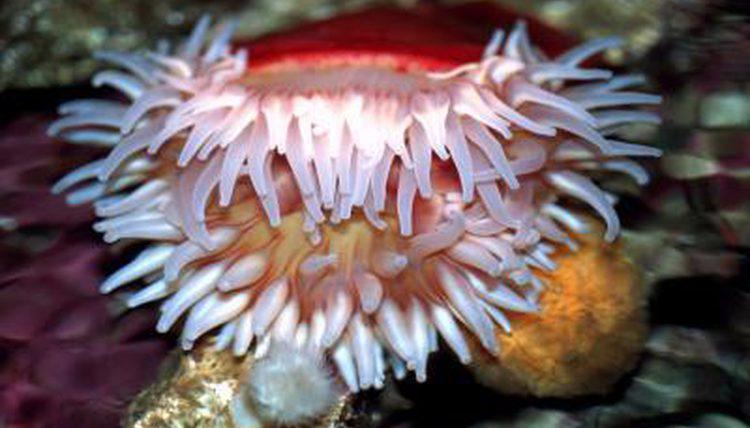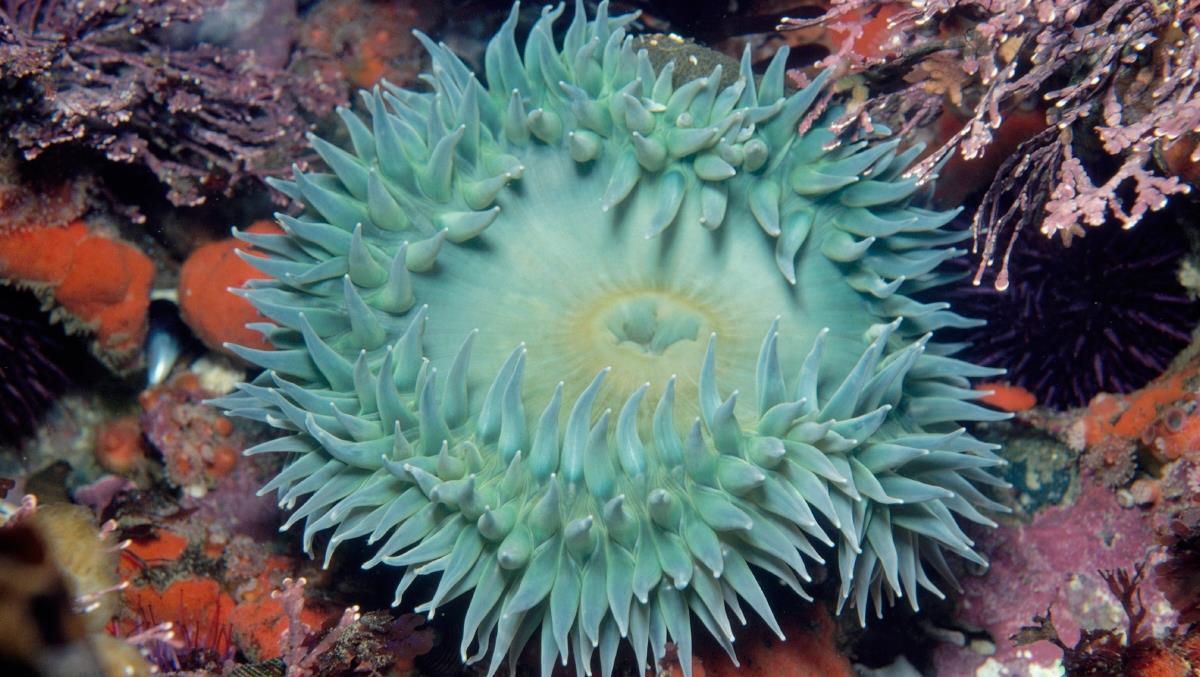The first image is the image on the left, the second image is the image on the right. For the images shown, is this caption "At least one anemone is red or green and another is white." true? Answer yes or no. Yes. The first image is the image on the left, the second image is the image on the right. Examine the images to the left and right. Is the description "The lefthand image contains an anemone with pink bits, the righthand image contains a mostly white anemone." accurate? Answer yes or no. No. 